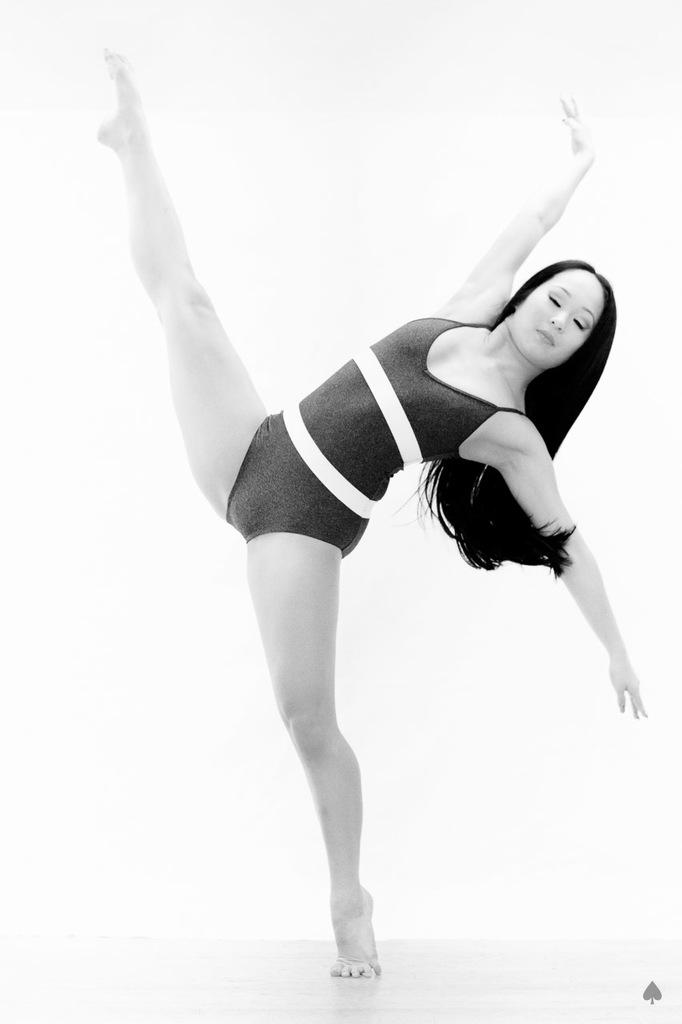What is the color scheme of the image? The image is black and white. What is located at the bottom of the image? There is a floor at the bottom of the image. What is the main subject of the image? A woman is dancing in the middle of the image. What type of vacation is the woman planning after her dance performance in the image? There is no information about a vacation or any plans related to the woman's dance performance in the image. 